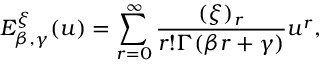<formula> <loc_0><loc_0><loc_500><loc_500>E _ { \beta , \gamma } ^ { \xi } ( u ) = \sum _ { r = 0 } ^ { \infty } \frac { ( \xi ) _ { r } } { r ! \Gamma ( \beta r + \gamma ) } u ^ { r } ,</formula> 